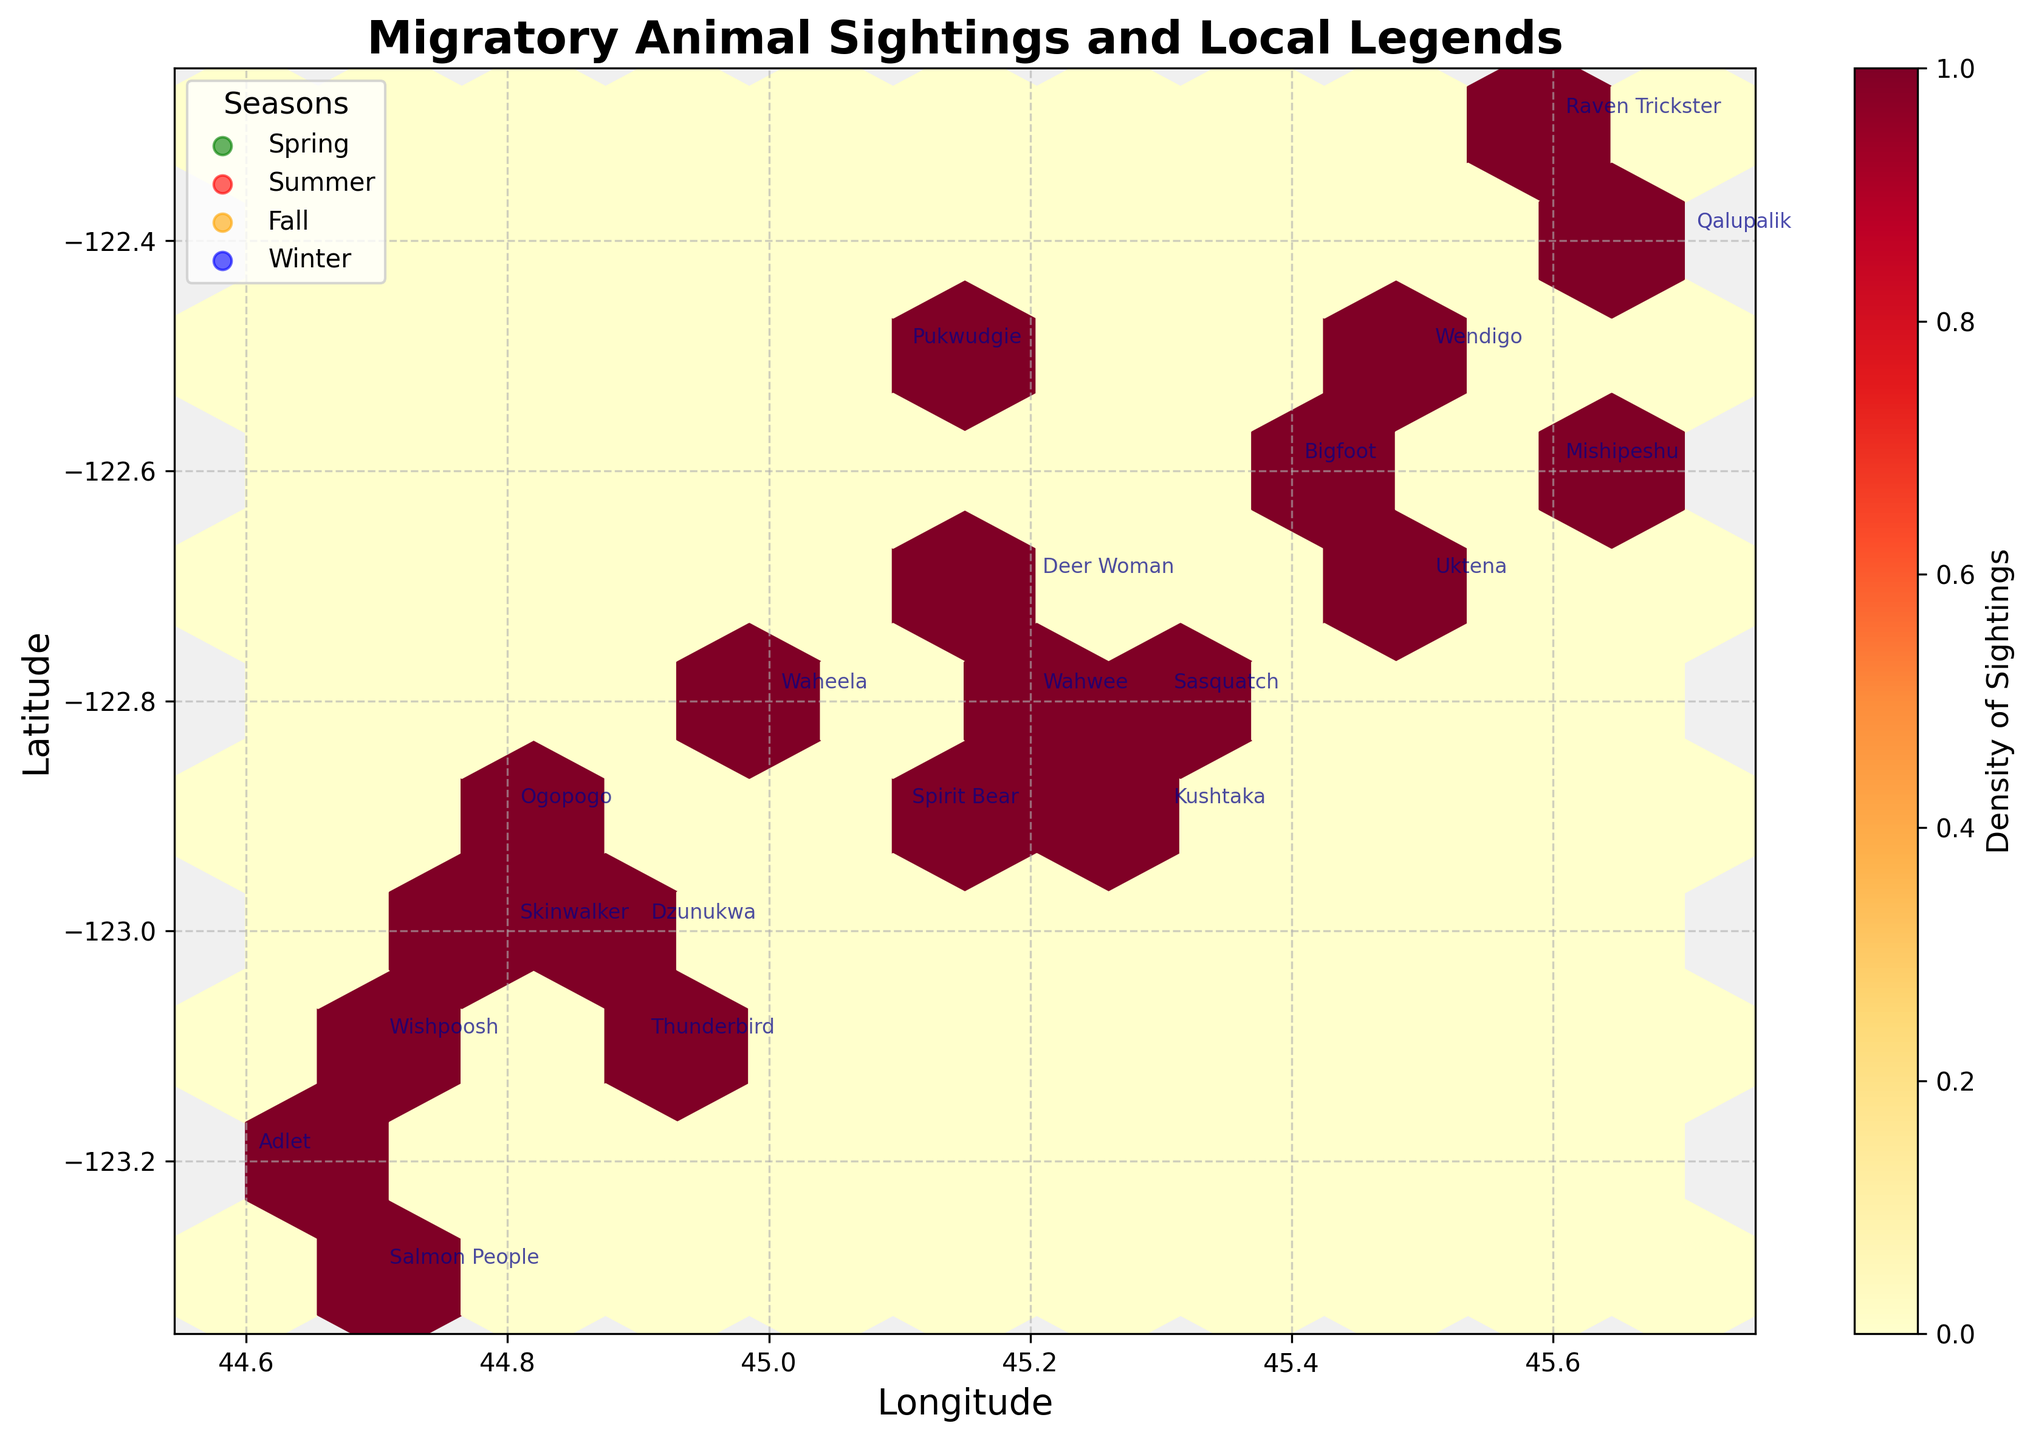What is the title of the plot? The title of a plot is usually displayed at the top of the figure. For this plot, the title is "Migratory Animal Sightings and Local Legends", which provides an overview of what the plot represents.
Answer: Migratory Animal Sightings and Local Legends How are the densities of sightings represented in the plot? In a hexbin plot, densities of sightings are usually represented by color intensity within each hexagon. In this plot, a color scale ranging from light yellow to dark red indicates densities, with darker colors showing higher densities.
Answer: By color intensity within hexagons Which season appears to have the highest density of sightings on the plot? The plot features a color gradient indicating density. By scanning the plot, we observe that the highest densities (dark red) cluster around red points, indicating Summer, meaning the sightings are most frequent in this season.
Answer: Summer What is the color used for sightings in Winter? The plot legend maps each season to a specific color. According to the legend, the color blue is used to represent Winter sightings.
Answer: Blue How many legends are annotated in the upper-left quadrant of the plot? The upper-left quadrant is identified by examining the distribution of points. Upon counting, there are four legends annotated in this quadrant, signifying different sightings.
Answer: Four Which legend appears closest to the center of the plot and what season is it associated with? By locating the approximate center of the plot at (45.1, -122.8), we find the legend "Deer Woman" in close proximity, which according to the annotations, is associated with Fall.
Answer: Deer Woman, Fall Is there a correlation between the density of sightings and a particular legend? By analyzing the density hotspots and legends annotated near them, particularly in Summer (red) areas, one can infer if a specific legend clusters around high-density zones. The plot doesn’t show an evident single legend dominating these zones.
Answer: No clear single legend Which two legends are located farthest apart on the plot, and in what seasons were they sighted? Identifying the legends located at the extremities of the plot, "Adlet" (Spring) and "Qalupalik" (Fall) appear the farthest. This can be verified by their coordinates and the spread across the plot.
Answer: Adlet (Spring) and Qalupalik (Fall) What is the average longitude of the sightings annotated on the plot? Calculate the average longitude by summing all the x-coordinates and dividing by the number of data points: (45.3 + 44.9 + 45.5 + 45.1 + 44.7 + 45.6 + 45.2 + 44.8 + 45.4 + 45.0 + 44.6 + 45.7 + 45.3 + 44.9 + 45.5 + 45.1 + 44.7 + 45.6 + 45.2 + 44.8)/20 = 45.086.
Answer: 45.086 